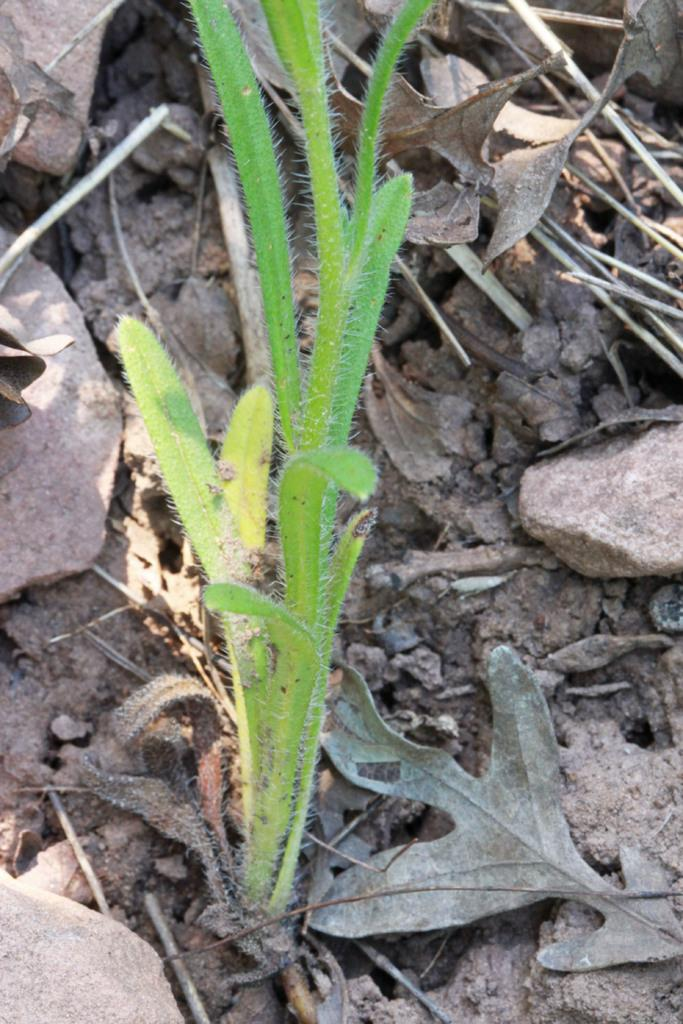What is the main subject in the middle of the image? There is a plant in the middle of the image. What can be seen behind the plant? There are stones and leaves visible behind the plant. What type of channel is visible in the image? There is no channel present in the image; it features a plant with stones and leaves behind it. Can you see a group of plastic items in the image? There is no group of plastic items present in the image. 